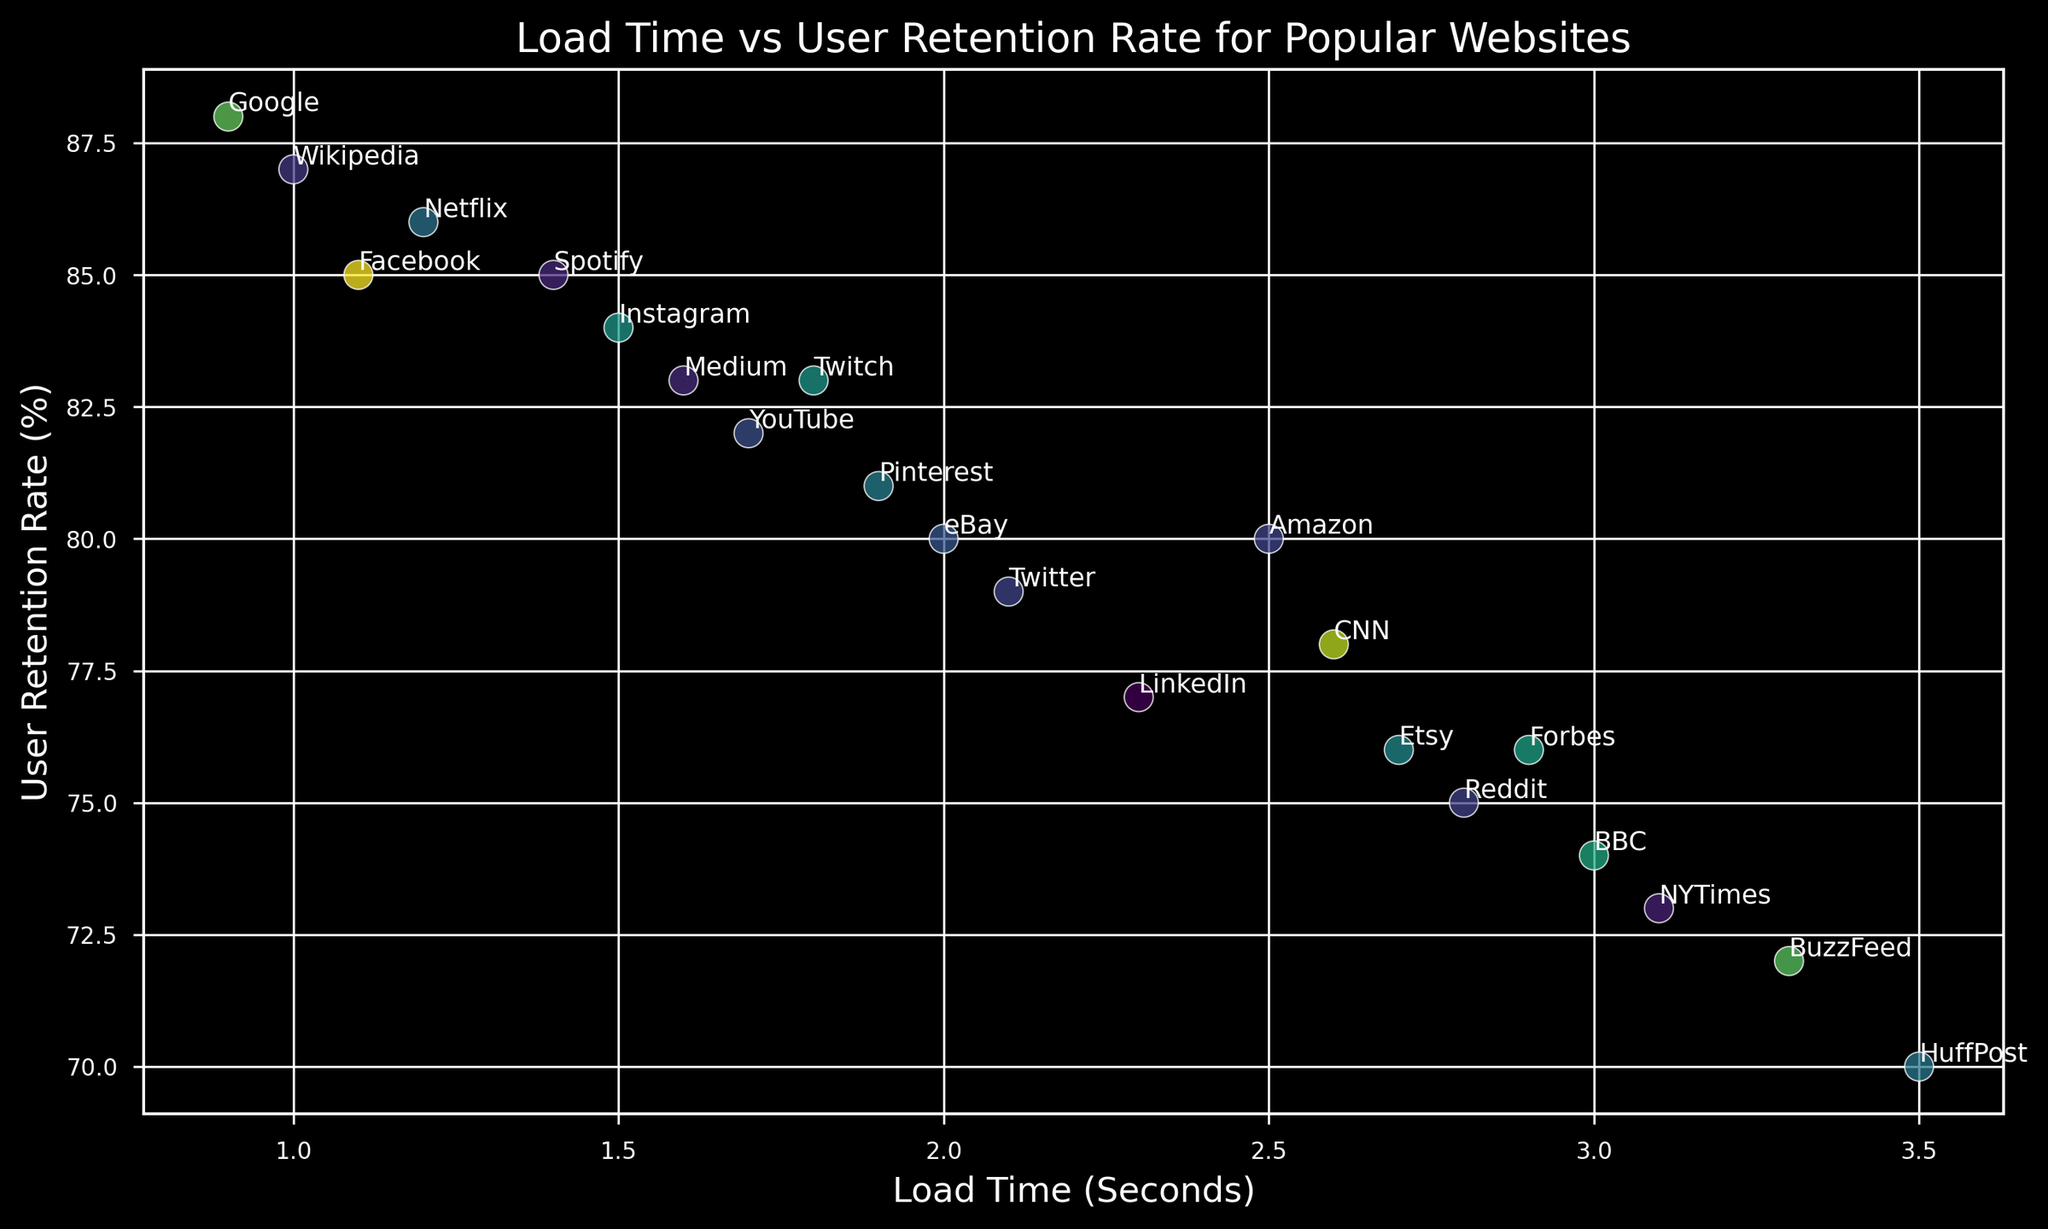What's the average user retention rate for websites with load times less than 2 seconds? First, identify the websites with load times less than 2 seconds: Facebook, Google, YouTube, Instagram, Netflix, Twitch, Spotify, Wikipedia, and Medium. Then, sum their user retention rates (85 + 88 + 82 + 84 + 86 + 83 + 85 + 87 + 83 = 763) and divide by the count (9). So, the average is 763 / 9 ≈ 84.78%
Answer: 84.78% Which website has the highest user retention rate and what is its load time? Identify the point with the highest y-value on the plot, which represents user retention rate. This point is Google with 88%. The corresponding load time from the x-axis is 0.9 seconds.
Answer: Google, 0.9 seconds Are there any websites with a load time greater than 3 seconds? If yes, list them. Look for points on the plot with an x-value greater than 3 seconds. The websites satisfying this condition are BBC, BuzzFeed, and HuffPost.
Answer: BBC, BuzzFeed, HuffPost Which website has the lowest user retention rate and what is its load time? Identify the point with the lowest y-value on the plot, which represents user retention rate. This point is HuffPost with 70%. The corresponding load time from the x-axis is 3.5 seconds.
Answer: HuffPost, 3.5 seconds How many websites have a user retention rate of 80% or more? Count the number of points on the plot with a y-value of 80% or more. The websites are Amazon, Facebook, Google, YouTube, Instagram, Netflix, Twitch, Spotify, Wikipedia, Pinterest, and eBay. There are 11 in total.
Answer: 11 Which website with a load time of less than 2 seconds has the highest user retention rate? Among the websites with load times less than 2 seconds (Facebook, Google, YouTube, Instagram, Netflix, Twitch, Spotify, Wikipedia, and Medium), Google has the highest user retention rate of 88%.
Answer: Google Compare the user retention rate for websites with load times of 2.5 seconds (Amazon) and 3.3 seconds (BuzzFeed). Amazon has a load time of 2.5 seconds with a user retention rate of 80%, while BuzzFeed has a load time of 3.3 seconds with a user retention rate of 72%.
Answer: Amazon: 80%, BuzzFeed: 72% What is the trend observed between load time and user retention rate for websites? Observing the scatter plot, it appears that as the load time increases, the user retention rate generally decreases, indicating a negative correlation.
Answer: Negative correlation Find the difference in user retention rates between Wikipedia and CNN. Wikipedia has a user retention rate of 87%, and CNN has a user retention rate of 78%. The difference is 87% - 78% = 9%.
Answer: 9% Which website has the closest user retention rate to LinkedIn and what is its load time? LinkedIn has a user retention rate of 77%. The closest retention rate on the plot is Forbes with a user retention rate also of 76%. The load time for Forbes is 2.9 seconds.
Answer: Forbes, 2.9 seconds 